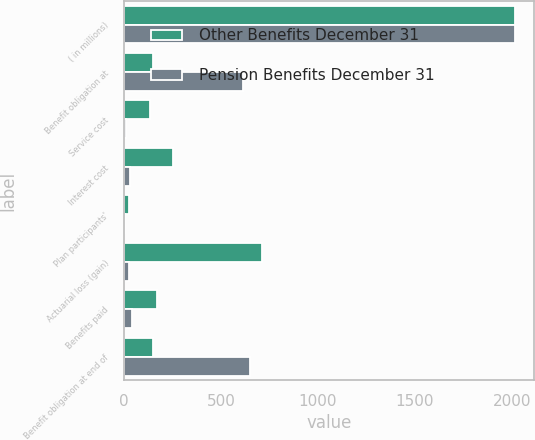Convert chart to OTSL. <chart><loc_0><loc_0><loc_500><loc_500><stacked_bar_chart><ecel><fcel>( in millions)<fcel>Benefit obligation at<fcel>Service cost<fcel>Interest cost<fcel>Plan participants'<fcel>Actuarial loss (gain)<fcel>Benefits paid<fcel>Benefit obligation at end of<nl><fcel>Other Benefits December 31<fcel>2014<fcel>152<fcel>136<fcel>253<fcel>26<fcel>714<fcel>168<fcel>152<nl><fcel>Pension Benefits December 31<fcel>2014<fcel>616<fcel>13<fcel>30<fcel>7<fcel>24<fcel>40<fcel>650<nl></chart> 